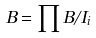<formula> <loc_0><loc_0><loc_500><loc_500>B = \prod B / I _ { i }</formula> 